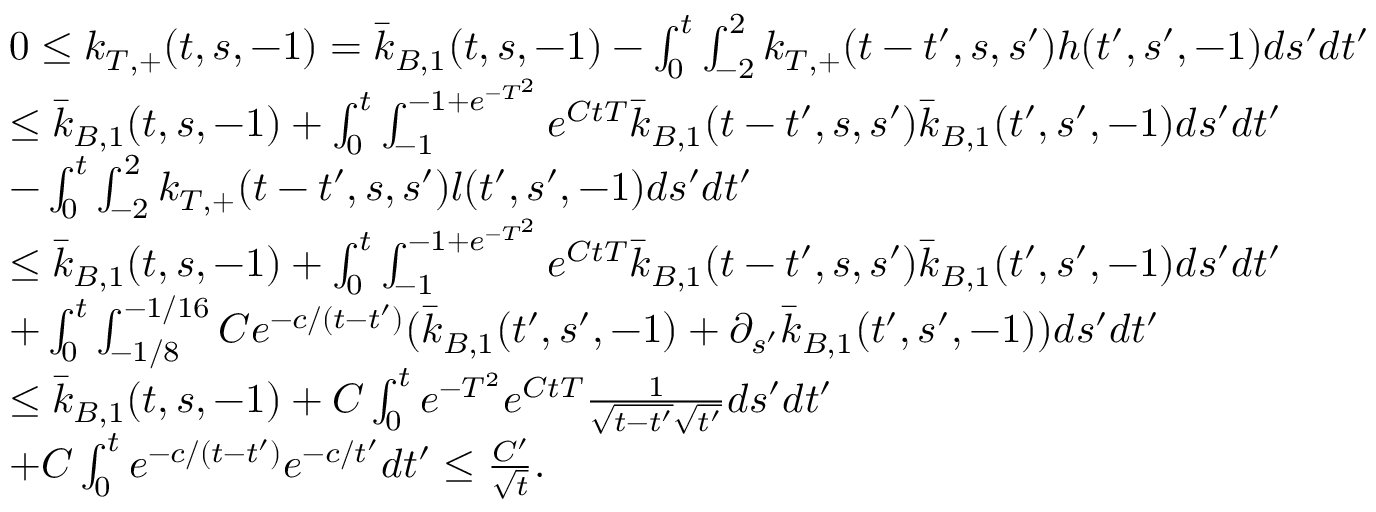<formula> <loc_0><loc_0><loc_500><loc_500>\begin{array} { r l } { \quad } & { 0 \leq k _ { T , + } ( t , s , - 1 ) = \bar { k } _ { B , 1 } ( t , s , - 1 ) - \int _ { 0 } ^ { t } \int _ { - 2 } ^ { 2 } k _ { T , + } ( t - t ^ { \prime } , s , s ^ { \prime } ) h ( t ^ { \prime } , s ^ { \prime } , - 1 ) d s ^ { \prime } d t ^ { \prime } } \\ & { \leq \bar { k } _ { B , 1 } ( t , s , - 1 ) + \int _ { 0 } ^ { t } \int _ { - 1 } ^ { - 1 + e ^ { - T ^ { 2 } } } e ^ { C t T } \bar { k } _ { B , 1 } ( t - t ^ { \prime } , s , s ^ { \prime } ) \bar { k } _ { B , 1 } ( t ^ { \prime } , s ^ { \prime } , - 1 ) d s ^ { \prime } d t ^ { \prime } } \\ & { - \int _ { 0 } ^ { t } \int _ { - 2 } ^ { 2 } k _ { T , + } ( t - t ^ { \prime } , s , s ^ { \prime } ) l ( t ^ { \prime } , s ^ { \prime } , - 1 ) d s ^ { \prime } d t ^ { \prime } } \\ & { \leq \bar { k } _ { B , 1 } ( t , s , - 1 ) + \int _ { 0 } ^ { t } \int _ { - 1 } ^ { - 1 + e ^ { - T ^ { 2 } } } e ^ { C t T } \bar { k } _ { B , 1 } ( t - t ^ { \prime } , s , s ^ { \prime } ) \bar { k } _ { B , 1 } ( t ^ { \prime } , s ^ { \prime } , - 1 ) d s ^ { \prime } d t ^ { \prime } } \\ & { + \int _ { 0 } ^ { t } \int _ { - 1 / 8 } ^ { - 1 / 1 6 } C e ^ { - c / ( t - t ^ { \prime } ) } ( \bar { k } _ { B , 1 } ( t ^ { \prime } , s ^ { \prime } , - 1 ) + \partial _ { s ^ { \prime } } \bar { k } _ { B , 1 } ( t ^ { \prime } , s ^ { \prime } , - 1 ) ) d s ^ { \prime } d t ^ { \prime } } \\ & { \leq \bar { k } _ { B , 1 } ( t , s , - 1 ) + C \int _ { 0 } ^ { t } e ^ { - T ^ { 2 } } e ^ { C t T } \frac { 1 } { \sqrt { t - t ^ { \prime } } \sqrt { t ^ { \prime } } } d s ^ { \prime } d t ^ { \prime } } \\ & { + C \int _ { 0 } ^ { t } e ^ { - c / ( t - t ^ { \prime } ) } e ^ { - c / t ^ { \prime } } d t ^ { \prime } \leq \frac { C ^ { \prime } } { \sqrt { t } } . } \end{array}</formula> 